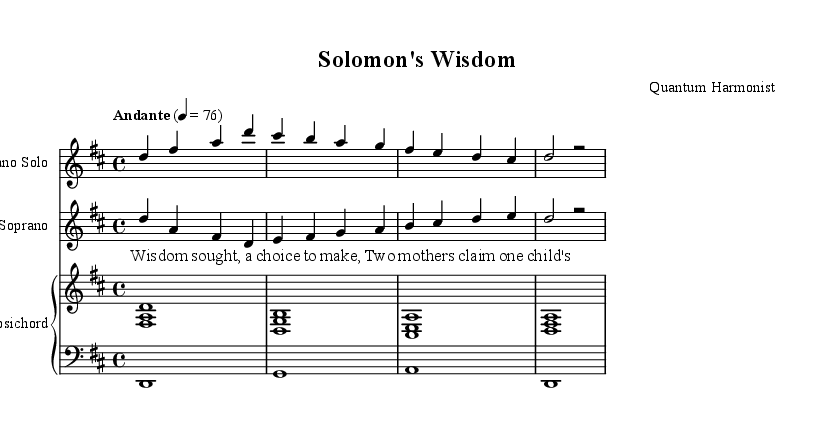What is the key signature of this music? The key signature indicates two sharps (F# and C#), which defines the music as being in D major.
Answer: D major What is the time signature of this music? The time signature is indicated at the beginning of the score and is represented as 4/4, meaning there are four beats per measure and a quarter note gets one beat.
Answer: 4/4 What is the tempo of this piece? The tempo marking appears above the staff and indicates "Andante" with a metronome marking of quarter note = 76, suggesting a moderate walking pace.
Answer: Andante, 76 What is the vocal type for the solo part? The instrument name specified for the solo part is "Soprano Solo," indicating that this section is meant for soprano female voice.
Answer: Soprano Solo How many measures are in the soprano solo? By counting the measures in the soprano solo section presented in the sheet music, it is evident there are four measures.
Answer: 4 What Biblical story is referenced in the lyrics? The lyrics refer to the story where two mothers claim one child, which points to the famous tale of King Solomon's judgment regarding wisdom and fairness.
Answer: Solomon's Judgment In what style is the accompanying instrument indicated? The score indicates the instrument is a "Harpsichord," which is typical of Baroque music and aligns with the oratorio style, offering a distinct timbre.
Answer: Harpsichord 